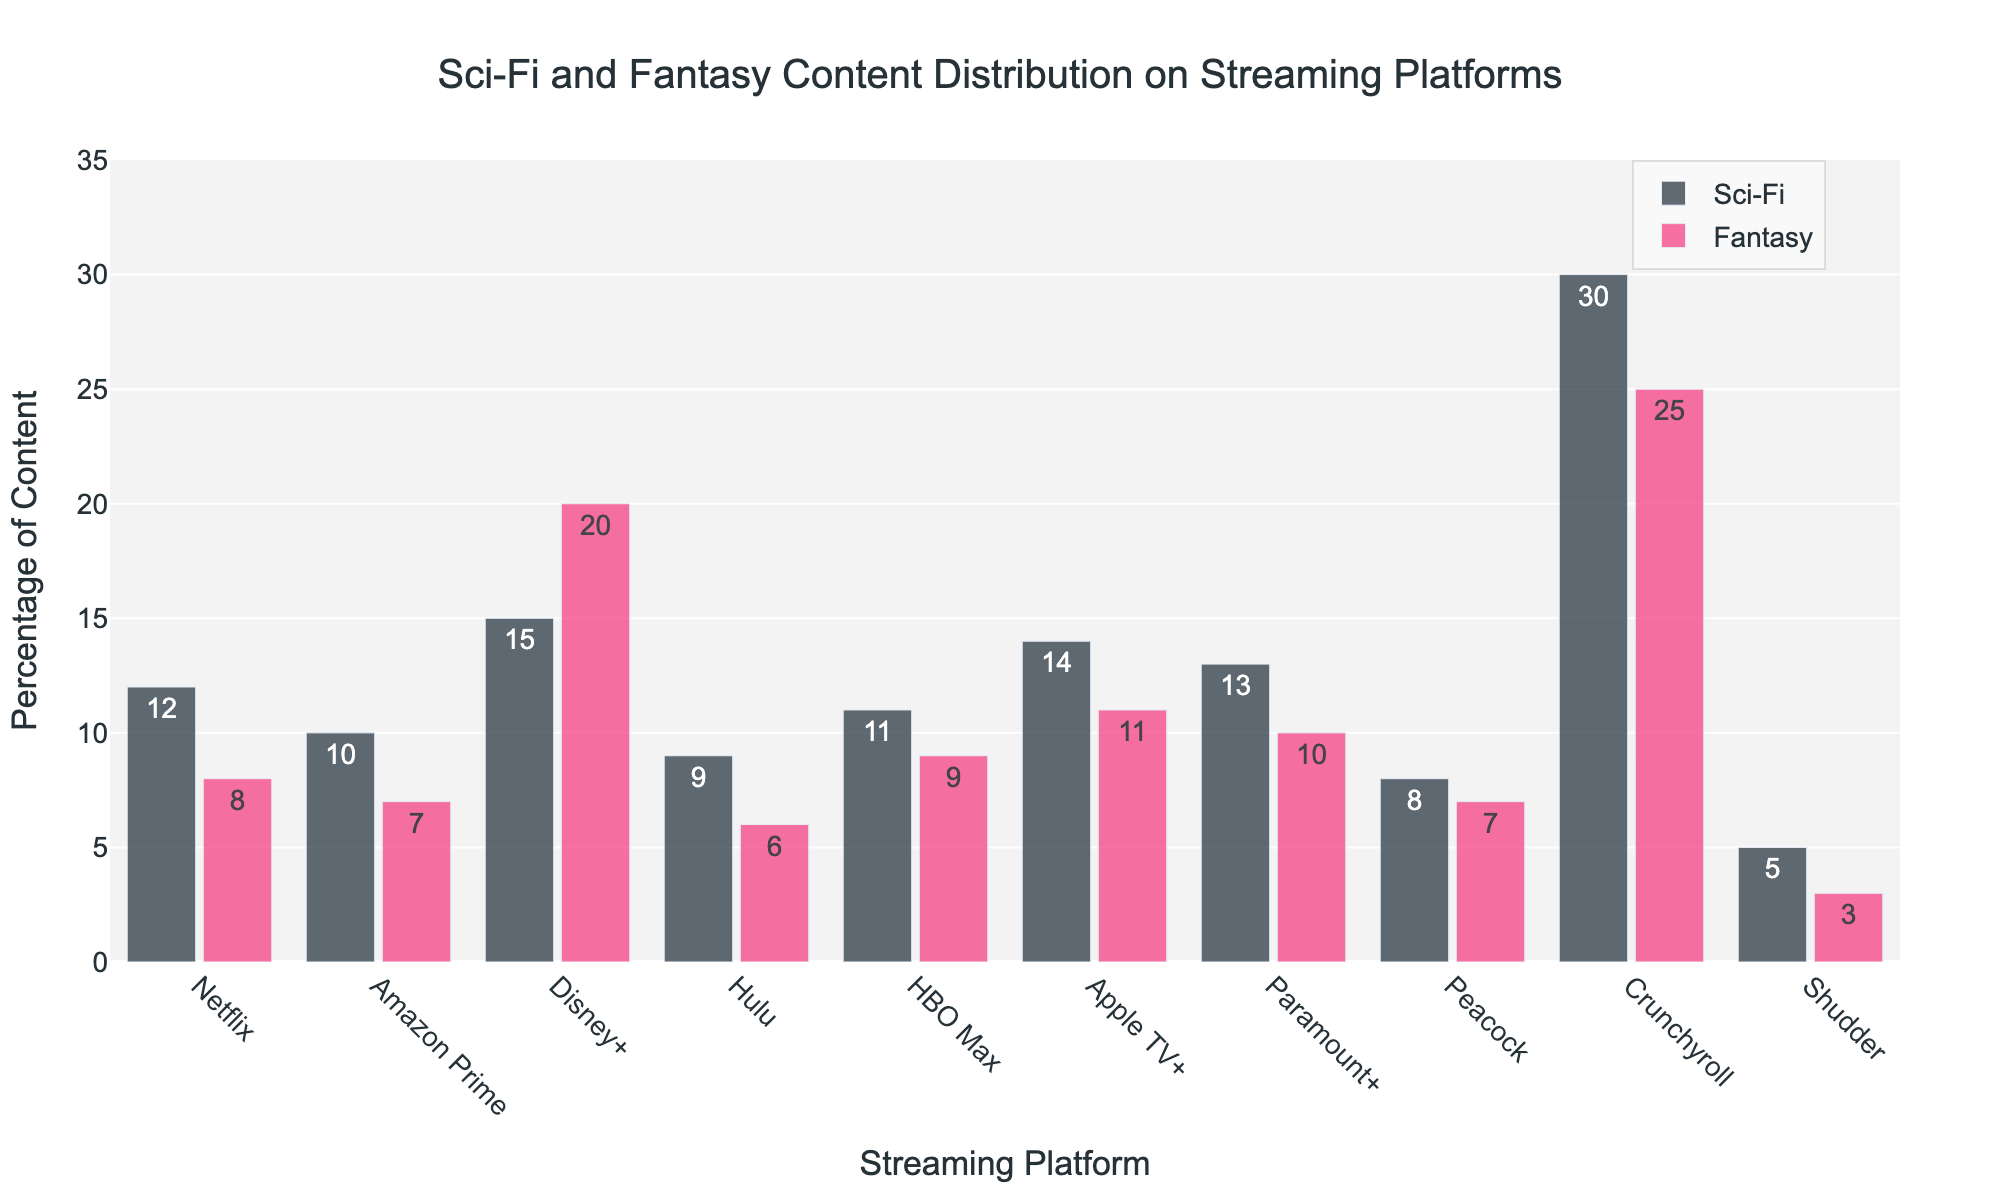What's the platform with the highest percentage of sci-fi content? To determine which platform has the highest sci-fi content, compare the heights of the sci-fi bars for each platform. The highest bar indicates the platform with the most sci-fi content.
Answer: Crunchyroll How much higher is Disney+'s fantasy content compared to Netflix's fantasy content? Identify the percentage of fantasy content for Disney+ and Netflix. Subtract Netflix's percentage (8%) from Disney+'s percentage (20%).
Answer: 12% Which platform has the lowest percentage of sci-fi content? Look for the platform with the shortest sci-fi bar.
Answer: Peacock On average, how much sci-fi content is there across all platforms? Sum up all sci-fi percentages: (12% + 10% + 15% + 9% + 11% + 14% + 13% + 8% + 30% + 5%) = 127%. Then, divide by the number of platforms (10). 127 / 10 = 12.7%.
Answer: 12.7% Which streaming platform has a higher percentage of sci-fi content than Peacock but lower than Apple TV+? Identify the platforms with sci-fi content between 8% (Peacock) and 14% (Apple TV+): Netflix (12%), HBO Max (11%), and Paramount+ (13%).
Answer: Netflix, HBO Max, Paramount+ Comparing fantasy content, how does Crunchyroll stand out visually compared to the other platforms? Visually, Crunchyroll has one of the tallest fantasy bars, differentiating it significantly in the visual representation as one of the platforms with high fantasy content.
Answer: Tallest fantasy bar Which platform has a more balanced distribution of sci-fi and fantasy content? "Balanced distribution" implies the sci-fi and fantasy percentages are close. Check platforms where these values are similar. Example: Crunchyroll (30% sci-fi, 25% fantasy) has close values.
Answer: Crunchyroll How much more sci-fi content does Hulu need to match Apple TV+'s sci-fi content? Subtract Hulu's sci-fi percentage (9%) from Apple TV+'s percentage (14%).
Answer: 5% Which platform has the closest percentage of sci-fi content to Amazon Prime? Identify the sci-fi percentage for Amazon Prime (10%) and find the platform with the percentage closest to this value: HBO Max (11%).
Answer: HBO Max 